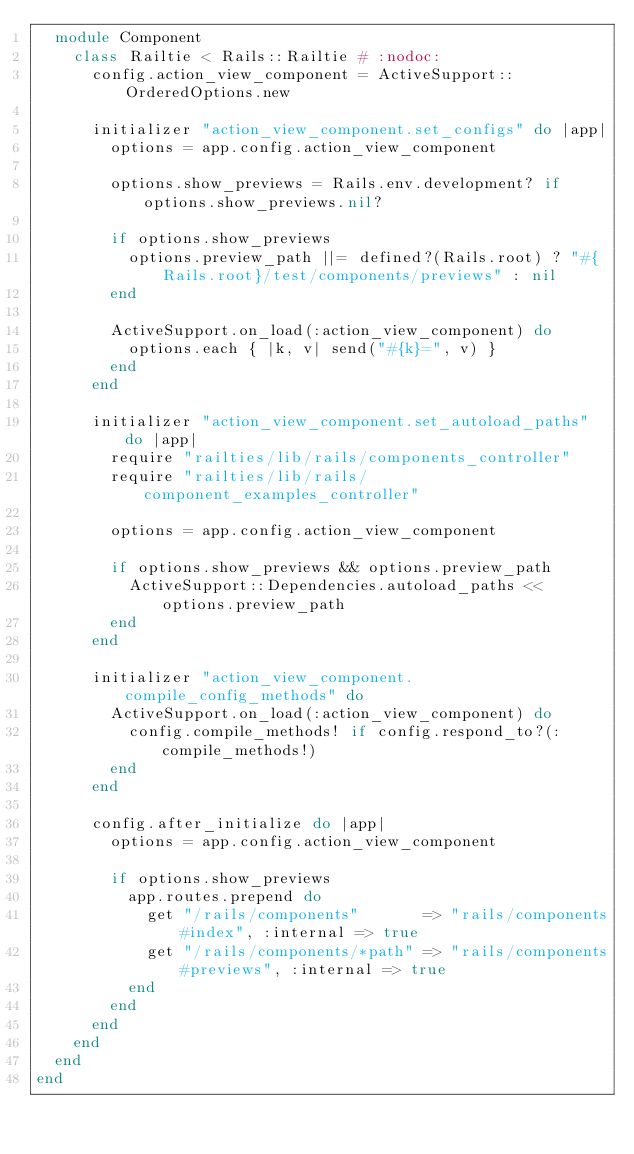Convert code to text. <code><loc_0><loc_0><loc_500><loc_500><_Ruby_>  module Component
    class Railtie < Rails::Railtie # :nodoc:
      config.action_view_component = ActiveSupport::OrderedOptions.new

      initializer "action_view_component.set_configs" do |app|
        options = app.config.action_view_component

        options.show_previews = Rails.env.development? if options.show_previews.nil?

        if options.show_previews
          options.preview_path ||= defined?(Rails.root) ? "#{Rails.root}/test/components/previews" : nil
        end

        ActiveSupport.on_load(:action_view_component) do
          options.each { |k, v| send("#{k}=", v) }
        end
      end

      initializer "action_view_component.set_autoload_paths" do |app|
        require "railties/lib/rails/components_controller"
        require "railties/lib/rails/component_examples_controller"

        options = app.config.action_view_component

        if options.show_previews && options.preview_path
          ActiveSupport::Dependencies.autoload_paths << options.preview_path
        end
      end

      initializer "action_view_component.compile_config_methods" do
        ActiveSupport.on_load(:action_view_component) do
          config.compile_methods! if config.respond_to?(:compile_methods!)
        end
      end

      config.after_initialize do |app|
        options = app.config.action_view_component

        if options.show_previews
          app.routes.prepend do
            get "/rails/components"       => "rails/components#index", :internal => true
            get "/rails/components/*path" => "rails/components#previews", :internal => true
          end
        end
      end
    end
  end
end
</code> 